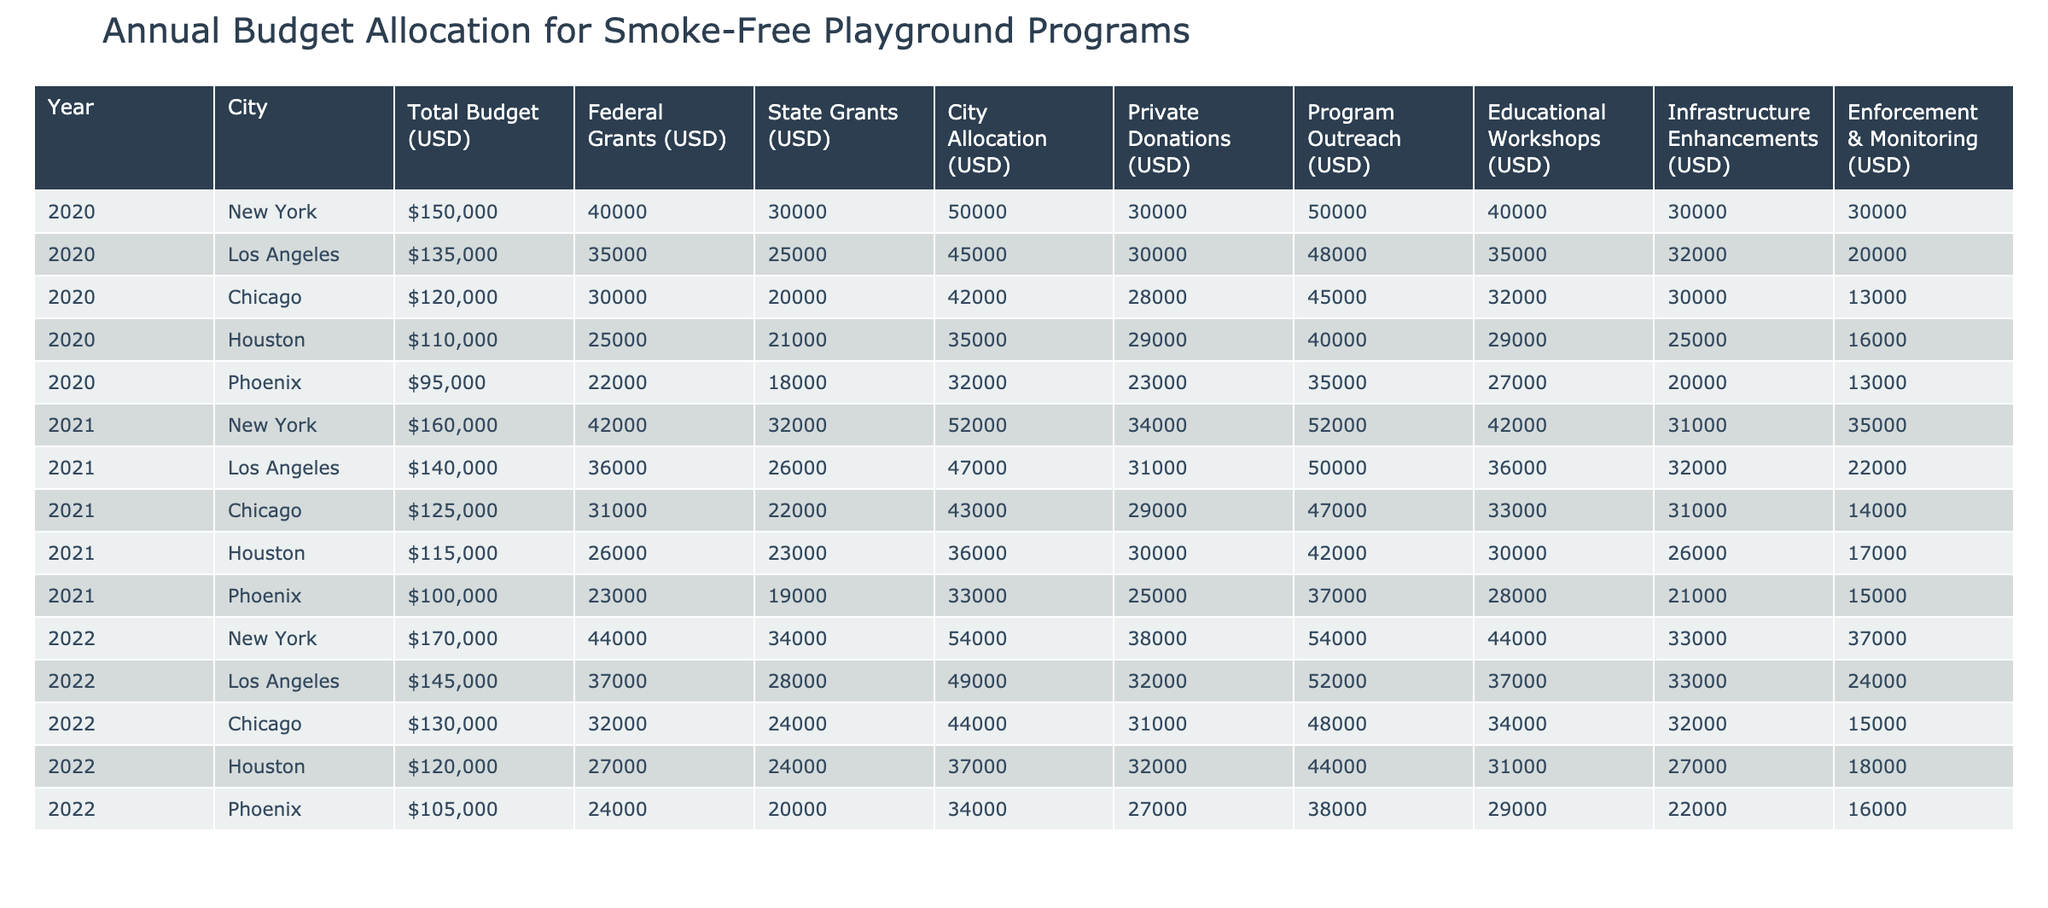What is the total budget for smoke-free playground programs in New York in 2021? The table shows the total budget in the row corresponding to New York for the year 2021. The value given is 160,000 USD.
Answer: 160000 USD What were the federal grants allocated to Houston in 2020? The federal grants for Houston in 2020 can be found in the corresponding row and column for that year. The amount listed is 25,000 USD.
Answer: 25000 USD Which city had the highest total budget in 2022? To answer this, we can compare the 'Total Budget (USD)' values for all cities listed in the year 2022. The value for New York is 170,000 USD, which is higher than other cities.
Answer: New York What is the average city allocation for all cities in 2020? First, I will sum the 'City Allocation (USD)' for each city in 2020: 50,000 + 45,000 + 42,000 + 35,000 + 32,000 = 204,000 USD. Then, I divide by the number of cities (5) to get the average: 204,000 / 5 = 40,800 USD.
Answer: 40800 USD Did Phoenix receive more private donations than Chicago in 2021? In 2021, the private donations for Phoenix was 25,000 USD and for Chicago it was 29,000 USD. Since 25,000 < 29,000, the statement is false.
Answer: No What was the change in federal grants for Los Angeles from 2020 to 2021? The federal grants for Los Angeles in 2020 are 35,000 USD, and in 2021 they are 36,000 USD. The difference is 36,000 - 35,000 = 1,000 USD, indicating an increase.
Answer: 1000 USD What percentage of the total budget in Chicago for 2022 was allocated to enforcement and monitoring? First, identify the total budget for Chicago in 2022, which is 130,000 USD. The amount allocated to enforcement and monitoring is 15,000 USD. Calculate the percentage: (15,000 / 130,000) * 100 = 11.54%.
Answer: 11.54% Which city saw a decline in total budget from 2020 to 2021? By looking at the total budget values for each city in both years, we examine New York (150,000 to 160,000 USD), Los Angeles (135,000 to 140,000 USD), Chicago (120,000 to 125,000 USD), Houston (110,000 to 115,000 USD), and Phoenix (95,000 to 100,000 USD). All cities experienced an increase.
Answer: None What is the total amount allocated to program outreach across all cities in 2020? I will add the values from the 'Program Outreach (USD)' column for each city in 2020: 50,000 + 48,000 + 45,000 + 40,000 + 35,000 = 218,000 USD.
Answer: 218000 USD 